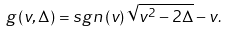<formula> <loc_0><loc_0><loc_500><loc_500>g \left ( v , \Delta \right ) = s g n \left ( v \right ) \sqrt { v ^ { 2 } - 2 \Delta } - v .</formula> 